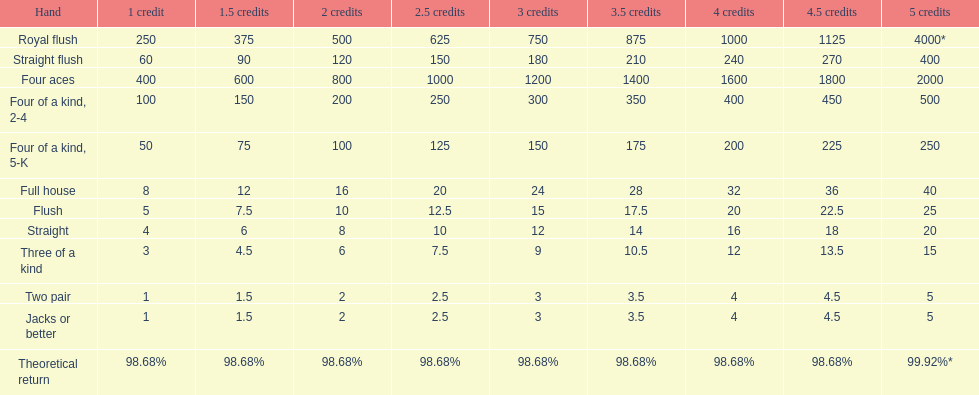The number of credits returned for a one credit bet on a royal flush are. 250. 